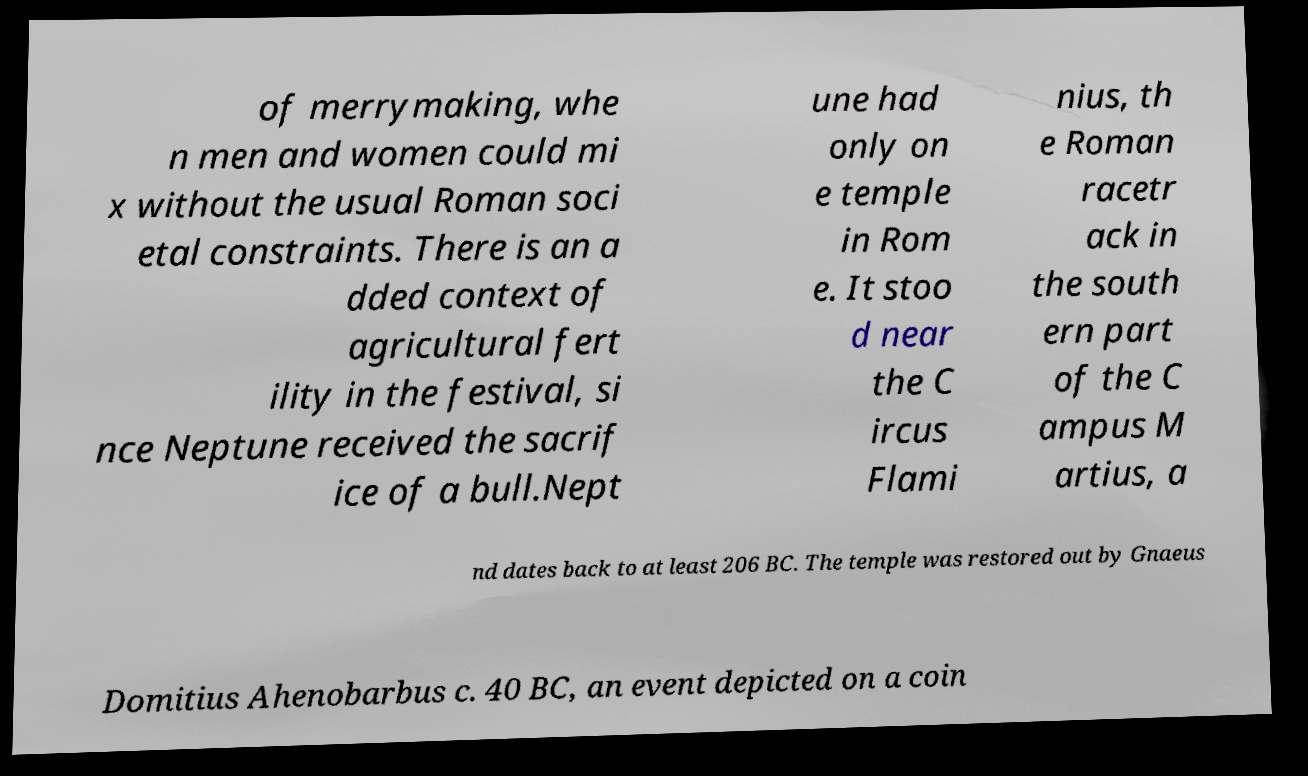Could you extract and type out the text from this image? of merrymaking, whe n men and women could mi x without the usual Roman soci etal constraints. There is an a dded context of agricultural fert ility in the festival, si nce Neptune received the sacrif ice of a bull.Nept une had only on e temple in Rom e. It stoo d near the C ircus Flami nius, th e Roman racetr ack in the south ern part of the C ampus M artius, a nd dates back to at least 206 BC. The temple was restored out by Gnaeus Domitius Ahenobarbus c. 40 BC, an event depicted on a coin 